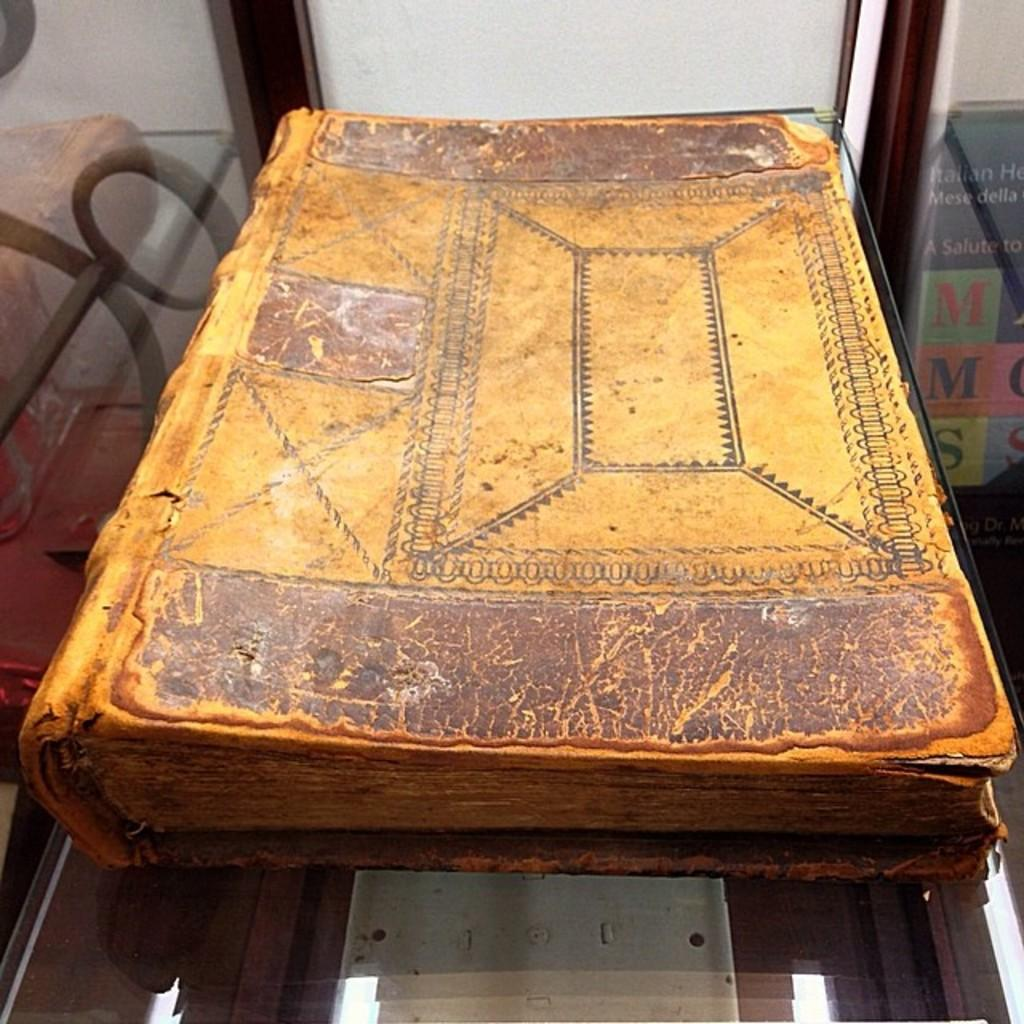What is the main subject of the image? The main subject of the image is an old book. Where is the old book located? The old book is on a glass table. What type of kitty can be seen sitting on the old book in the image? There is no kitty present on the old book in the image. How many companies are visible in the image? There are no companies visible in the image; it features an old book on a glass table. 